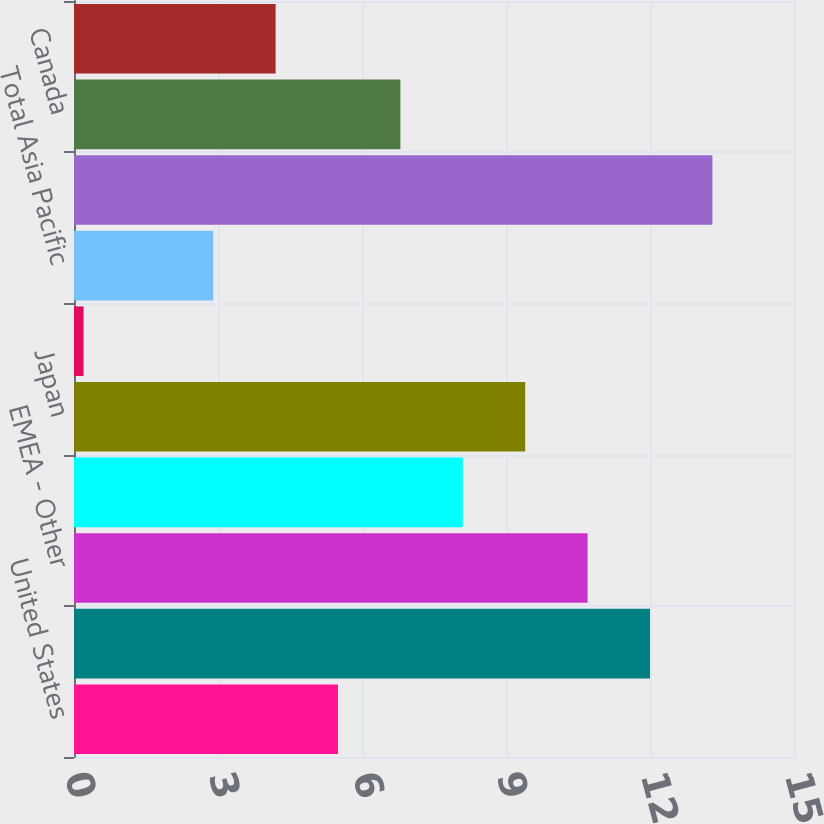Convert chart. <chart><loc_0><loc_0><loc_500><loc_500><bar_chart><fcel>United States<fcel>Europe (b)<fcel>EMEA - Other<fcel>Total EMEA<fcel>Japan<fcel>Asia Pacific - Other<fcel>Total Asia Pacific<fcel>Latin America<fcel>Canada<fcel>Total International Retail<nl><fcel>5.5<fcel>12<fcel>10.7<fcel>8.1<fcel>9.4<fcel>0.2<fcel>2.9<fcel>13.3<fcel>6.8<fcel>4.2<nl></chart> 